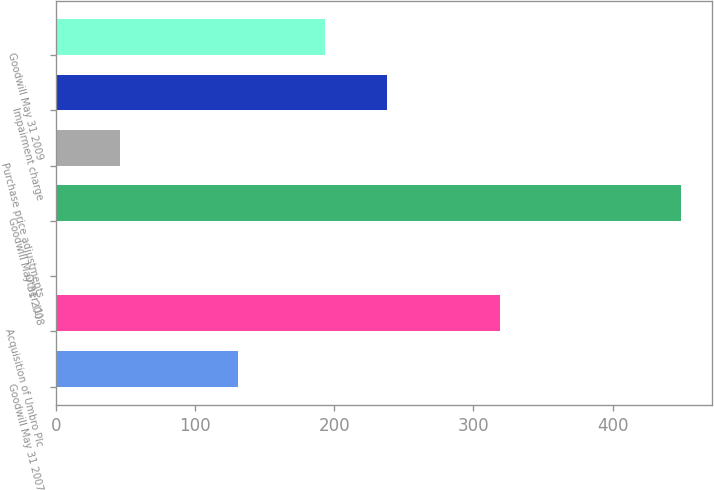Convert chart. <chart><loc_0><loc_0><loc_500><loc_500><bar_chart><fcel>Goodwill May 31 2007<fcel>Acquisition of Umbro Plc<fcel>Other (1)<fcel>Goodwill May 31 2008<fcel>Purchase price adjustments<fcel>Impairment charge<fcel>Goodwill May 31 2009<nl><fcel>130.8<fcel>319.2<fcel>1.2<fcel>448.8<fcel>45.96<fcel>238.26<fcel>193.5<nl></chart> 